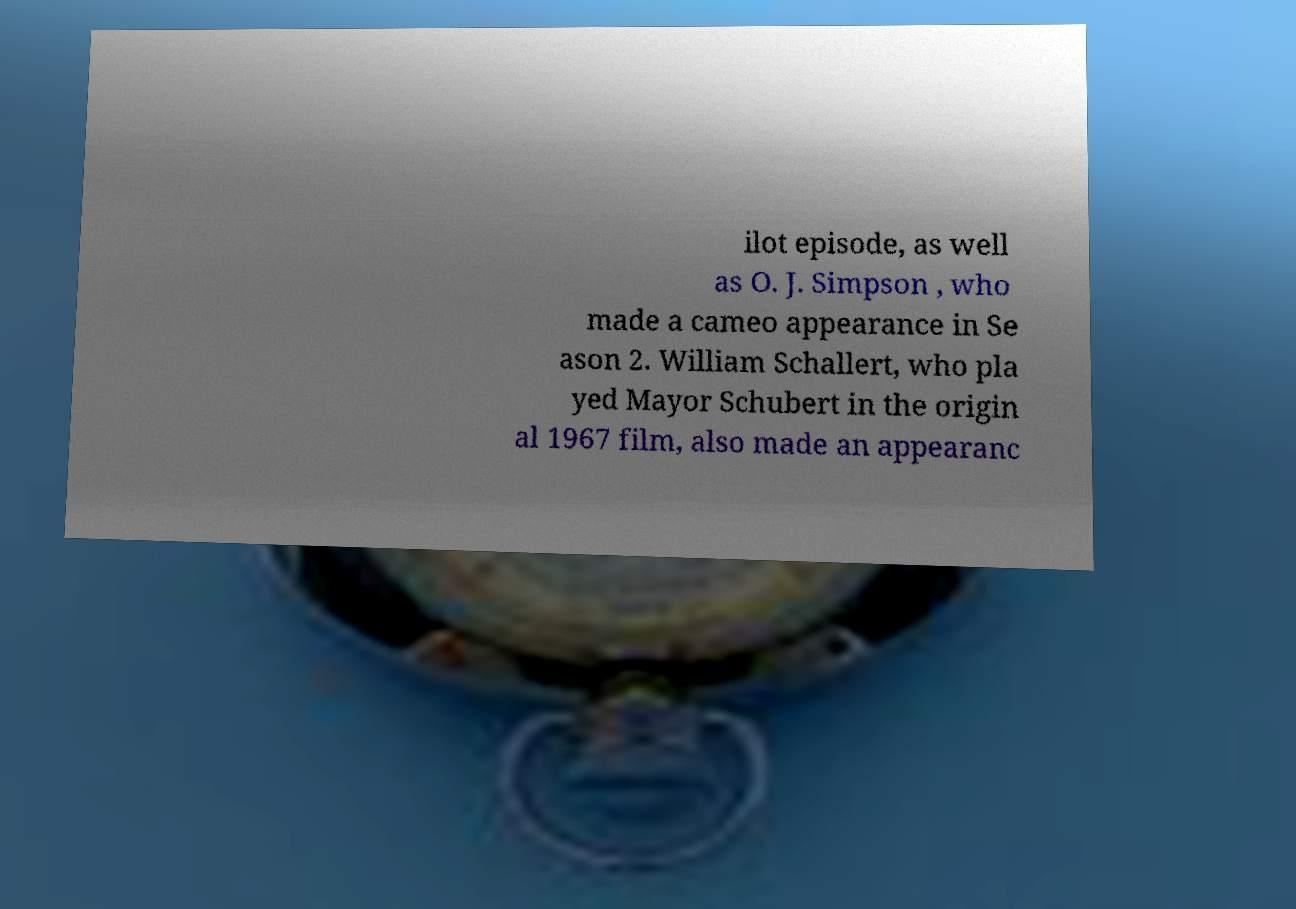Could you assist in decoding the text presented in this image and type it out clearly? ilot episode, as well as O. J. Simpson , who made a cameo appearance in Se ason 2. William Schallert, who pla yed Mayor Schubert in the origin al 1967 film, also made an appearanc 